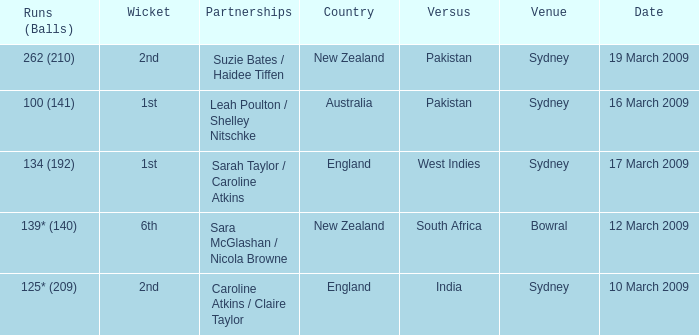How many times was the opponent country India?  1.0. 